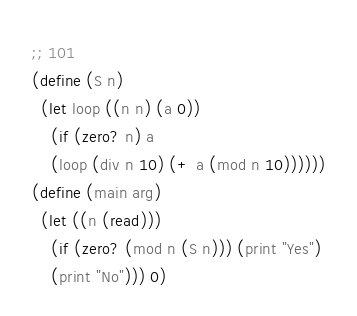<code> <loc_0><loc_0><loc_500><loc_500><_Scheme_>;; 101
(define (S n)
  (let loop ((n n) (a 0))
    (if (zero? n) a
	(loop (div n 10) (+ a (mod n 10))))))
(define (main arg)
  (let ((n (read)))
    (if (zero? (mod n (S n))) (print "Yes")
	(print "No"))) 0)</code> 